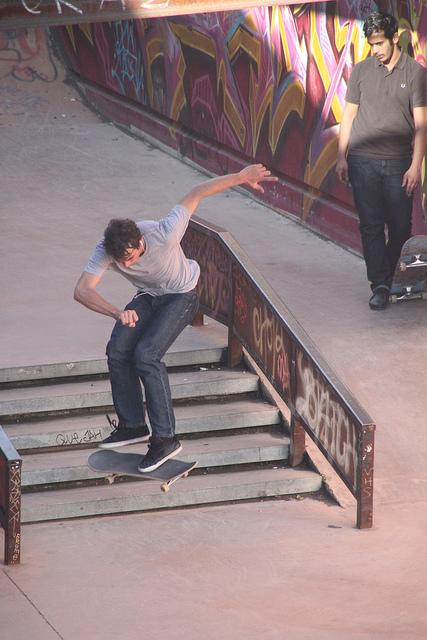How many people in the picture?
Short answer required. 2. Are the people impressed by the skater's performance?
Quick response, please. No. What is enclosing the skate park?
Be succinct. Wall. IS the man in the air?
Concise answer only. Yes. How many steps are visible?
Quick response, please. 5. Is it dark outside?
Concise answer only. No. How many steps are there?
Answer briefly. 5. He is indoors or out?
Quick response, please. Out. Is it really safe to be doing this?
Keep it brief. No. Is this called a flip-over?
Answer briefly. No. 